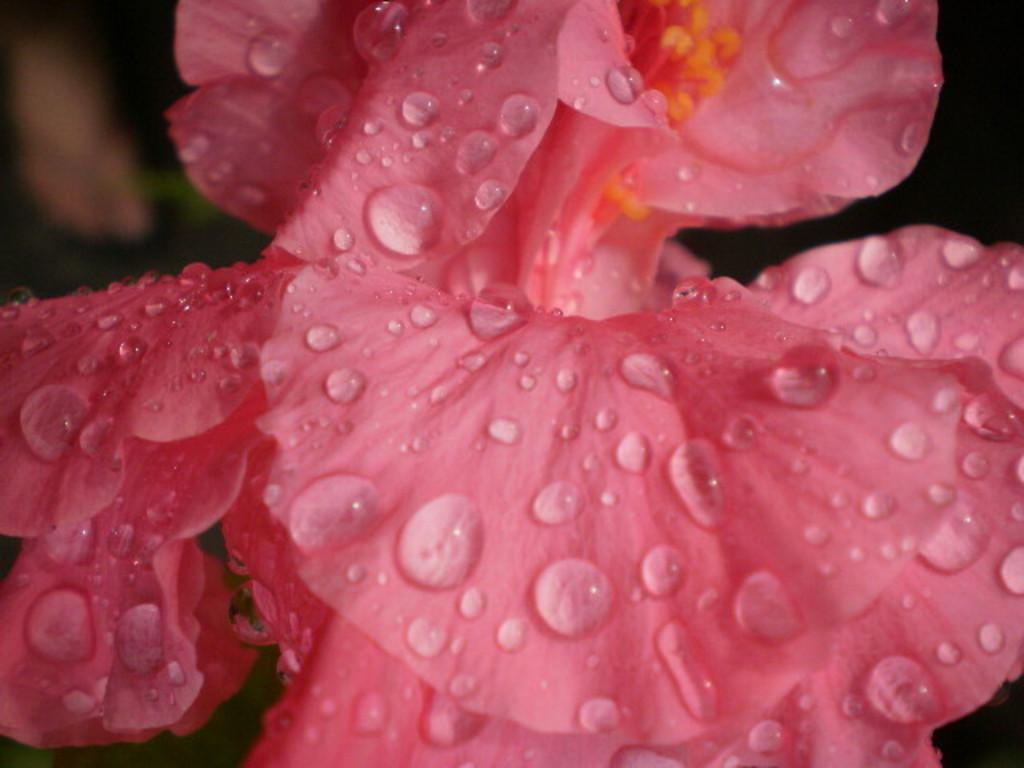What type of flower is in the image? There is a pink color flower in the image. What is the color of the background in the image? The background of the image is dark. Can you tell if the image was taken during the day or night? The image may have been taken during the night, given the dark background. What is the tendency of the flower to copy the behavior of other flowers in the image? There is no indication in the image that the flower is copying the behavior of other flowers, as flowers do not exhibit such behavior. 